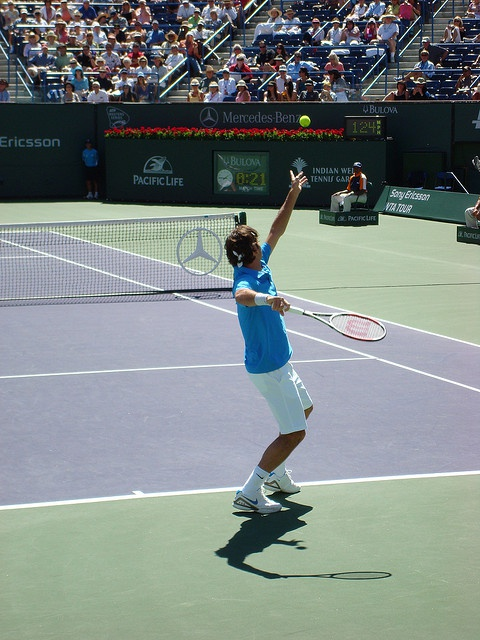Describe the objects in this image and their specific colors. I can see people in olive, black, gray, maroon, and navy tones, people in olive, blue, darkgray, gray, and black tones, tennis racket in olive, lightgray, darkgray, and pink tones, people in olive, black, gray, maroon, and darkgray tones, and people in olive, black, navy, darkblue, and gray tones in this image. 